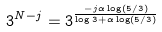<formula> <loc_0><loc_0><loc_500><loc_500>3 ^ { N - j } = 3 ^ { \frac { - j \alpha \log ( 5 / 3 ) } { \log 3 + \alpha \log ( 5 / 3 ) } }</formula> 